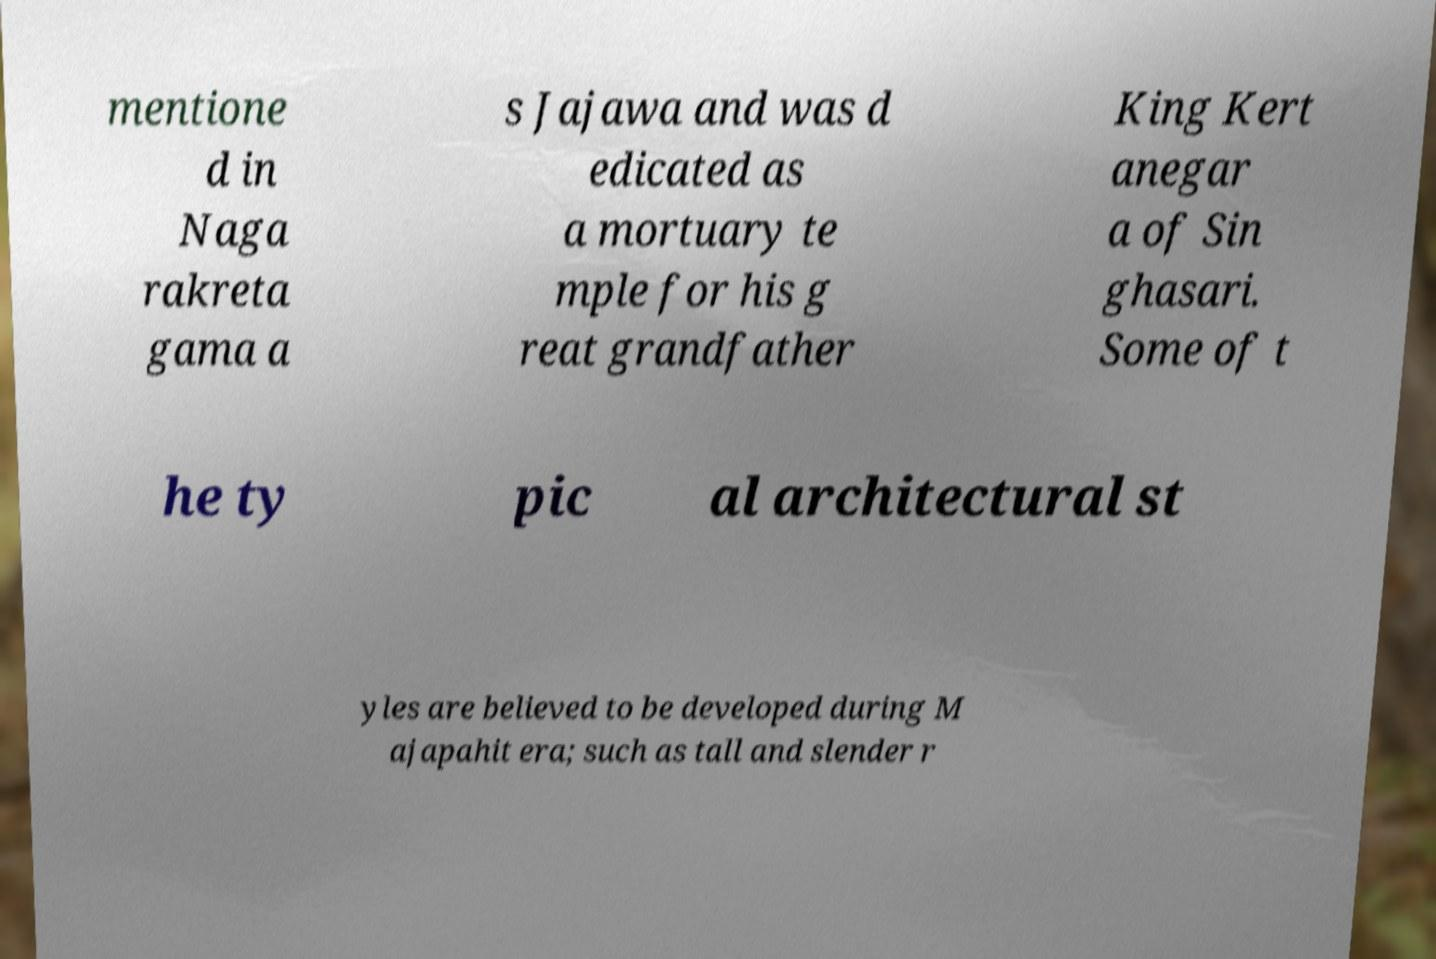Please read and relay the text visible in this image. What does it say? mentione d in Naga rakreta gama a s Jajawa and was d edicated as a mortuary te mple for his g reat grandfather King Kert anegar a of Sin ghasari. Some of t he ty pic al architectural st yles are believed to be developed during M ajapahit era; such as tall and slender r 